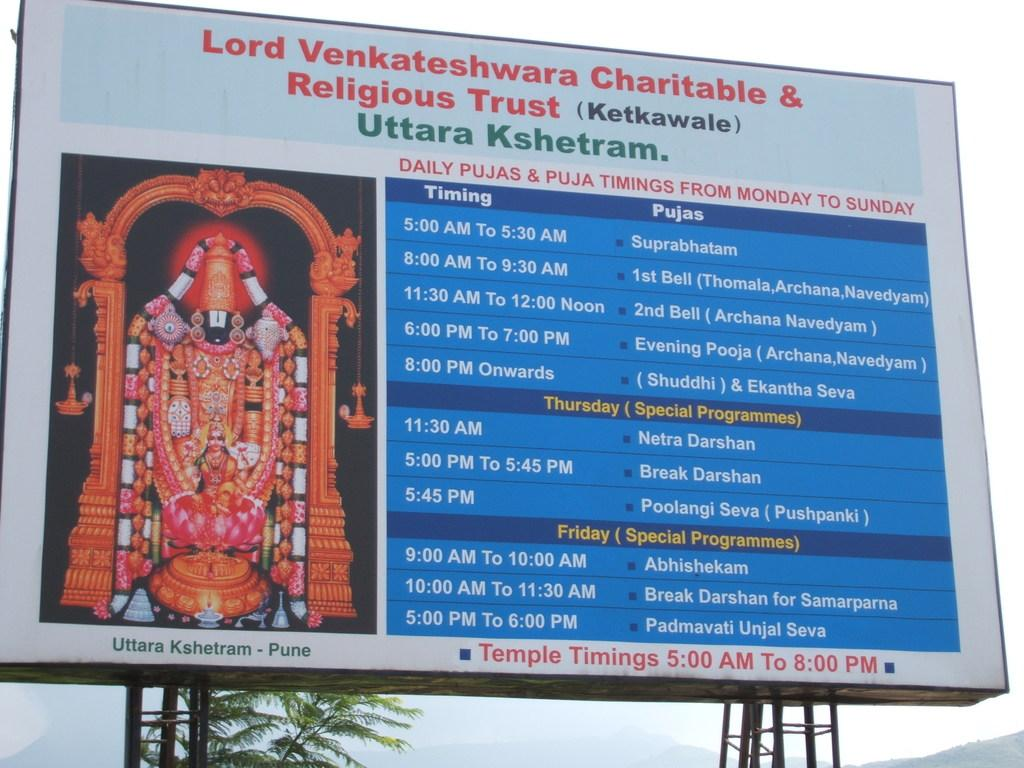<image>
Give a short and clear explanation of the subsequent image. Big banner that includes timing and programming for temple daily times 